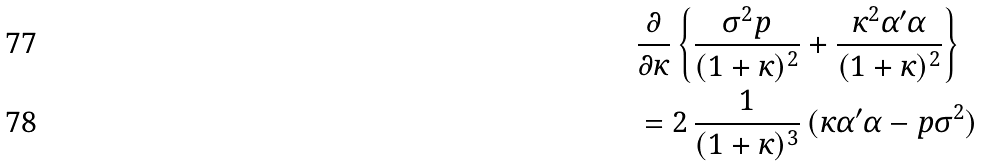<formula> <loc_0><loc_0><loc_500><loc_500>& \frac { \partial } { \partial \kappa } \left \{ \frac { \sigma ^ { 2 } p } { ( 1 + \kappa ) ^ { 2 } } + \frac { \kappa ^ { 2 } \alpha ^ { \prime } \alpha } { ( 1 + \kappa ) ^ { 2 } } \right \} \\ & = 2 \, \frac { 1 } { ( 1 + \kappa ) ^ { 3 } } \, ( \kappa \alpha ^ { \prime } \alpha - p \sigma ^ { 2 } )</formula> 